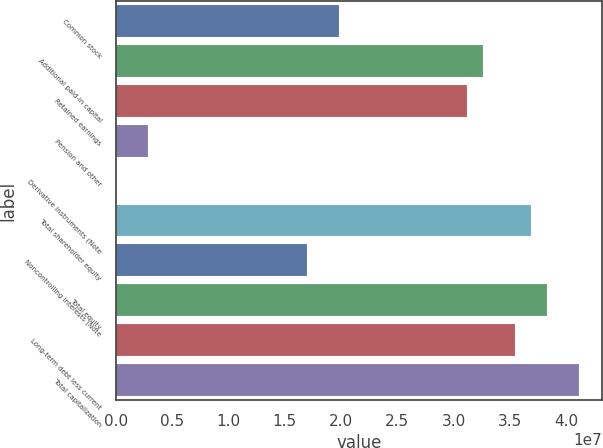Convert chart to OTSL. <chart><loc_0><loc_0><loc_500><loc_500><bar_chart><fcel>Common stock<fcel>Additional paid-in capital<fcel>Retained earnings<fcel>Pension and other<fcel>Derivative instruments (Note<fcel>Total shareholder equity<fcel>Noncontrolling interests (Note<fcel>Total equity<fcel>Long-term debt less current<fcel>Total capitalization<nl><fcel>1.98624e+07<fcel>3.26243e+07<fcel>3.12063e+07<fcel>2.84638e+06<fcel>10385<fcel>3.68783e+07<fcel>1.70264e+07<fcel>3.82963e+07<fcel>3.54603e+07<fcel>4.11323e+07<nl></chart> 